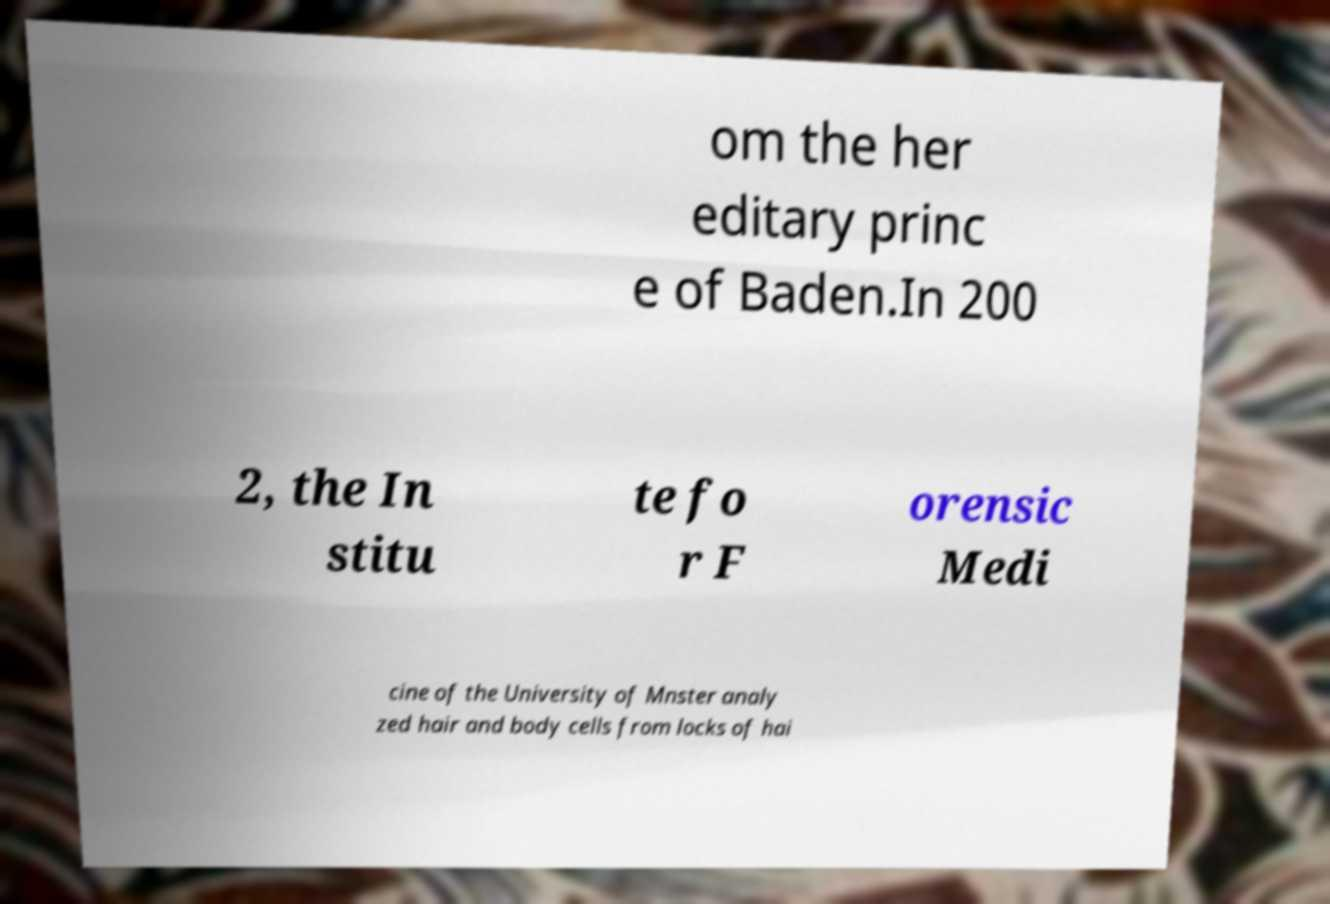Can you accurately transcribe the text from the provided image for me? om the her editary princ e of Baden.In 200 2, the In stitu te fo r F orensic Medi cine of the University of Mnster analy zed hair and body cells from locks of hai 